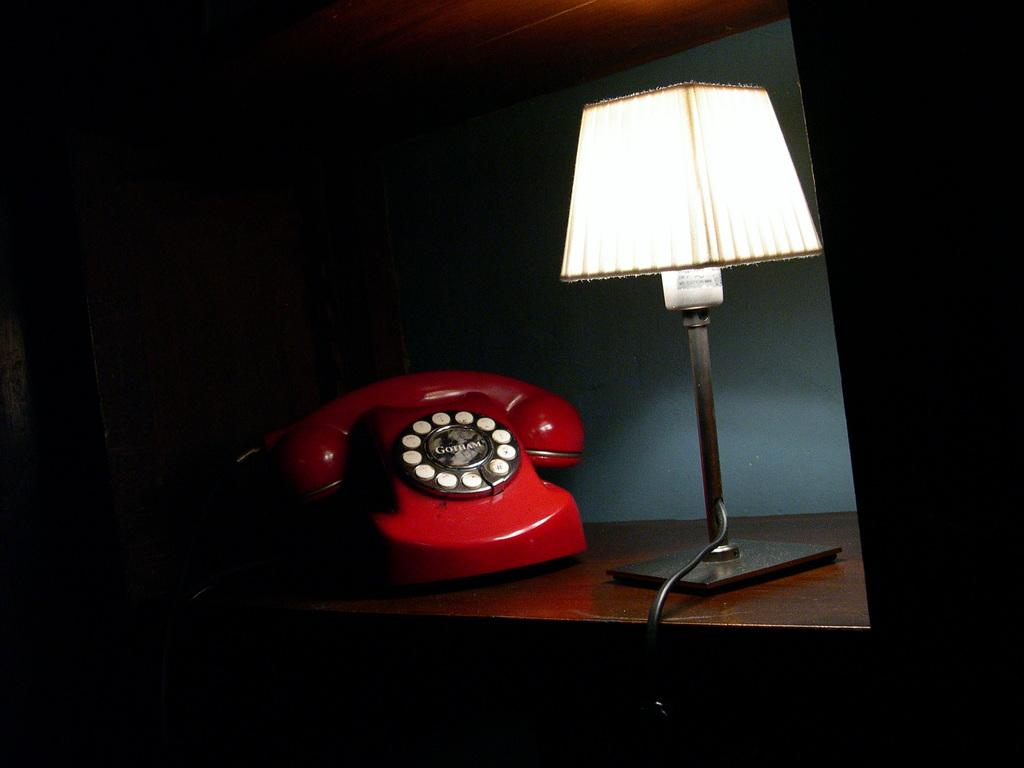What type of telephone is on the table in the image? There is a red color telephone on the table. What other object is on the table in the image? There is a lamp on the table. What type of hammer is used to adjust the time on the whistle in the image? There is no hammer, time, or whistle present in the image. 